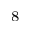Convert formula to latex. <formula><loc_0><loc_0><loc_500><loc_500>^ { 8 }</formula> 